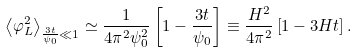<formula> <loc_0><loc_0><loc_500><loc_500>\left < \varphi ^ { 2 } _ { L } \right > _ { \frac { 3 t } { \psi _ { 0 } } \ll 1 } \simeq \frac { 1 } { 4 \pi ^ { 2 } \psi ^ { 2 } _ { 0 } } \left [ 1 - \frac { 3 t } { \psi _ { 0 } } \right ] \equiv \frac { H ^ { 2 } } { 4 \pi ^ { 2 } } \left [ 1 - 3 H t \right ] .</formula> 